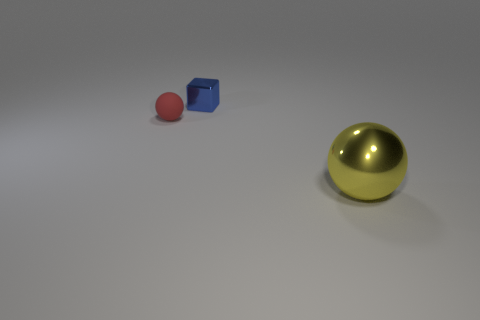Add 2 blocks. How many objects exist? 5 Subtract all yellow balls. How many balls are left? 1 Subtract all cubes. How many objects are left? 2 Subtract 1 balls. How many balls are left? 1 Subtract 0 gray cylinders. How many objects are left? 3 Subtract all brown blocks. Subtract all purple cylinders. How many blocks are left? 1 Subtract all cyan cylinders. How many yellow spheres are left? 1 Subtract all big purple shiny spheres. Subtract all metallic spheres. How many objects are left? 2 Add 3 small blue metallic cubes. How many small blue metallic cubes are left? 4 Add 3 tiny blue metallic things. How many tiny blue metallic things exist? 4 